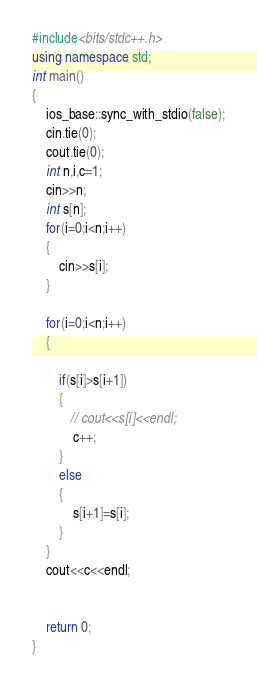Convert code to text. <code><loc_0><loc_0><loc_500><loc_500><_C++_>#include<bits/stdc++.h>
using namespace std;
int main()
{
    ios_base::sync_with_stdio(false);
    cin.tie(0);
    cout.tie(0);
    int n,i,c=1;
    cin>>n;
    int s[n];
    for(i=0;i<n;i++)
    {
        cin>>s[i];
    }

    for(i=0;i<n;i++)
    {

        if(s[i]>s[i+1])
        {
           // cout<<s[i]<<endl;
            c++;
        }
        else
        {
            s[i+1]=s[i];
        }
    }
    cout<<c<<endl;


    return 0;
}</code> 